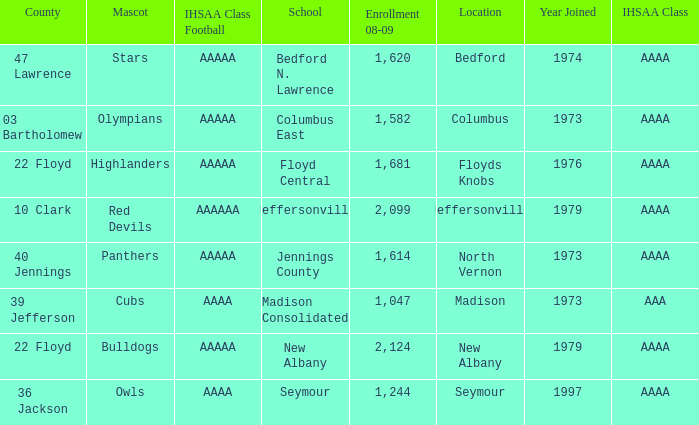What school is in 36 Jackson? Seymour. Parse the full table. {'header': ['County', 'Mascot', 'IHSAA Class Football', 'School', 'Enrollment 08-09', 'Location', 'Year Joined', 'IHSAA Class'], 'rows': [['47 Lawrence', 'Stars', 'AAAAA', 'Bedford N. Lawrence', '1,620', 'Bedford', '1974', 'AAAA'], ['03 Bartholomew', 'Olympians', 'AAAAA', 'Columbus East', '1,582', 'Columbus', '1973', 'AAAA'], ['22 Floyd', 'Highlanders', 'AAAAA', 'Floyd Central', '1,681', 'Floyds Knobs', '1976', 'AAAA'], ['10 Clark', 'Red Devils', 'AAAAAA', 'Jeffersonville', '2,099', 'Jeffersonville', '1979', 'AAAA'], ['40 Jennings', 'Panthers', 'AAAAA', 'Jennings County', '1,614', 'North Vernon', '1973', 'AAAA'], ['39 Jefferson', 'Cubs', 'AAAA', 'Madison Consolidated', '1,047', 'Madison', '1973', 'AAA'], ['22 Floyd', 'Bulldogs', 'AAAAA', 'New Albany', '2,124', 'New Albany', '1979', 'AAAA'], ['36 Jackson', 'Owls', 'AAAA', 'Seymour', '1,244', 'Seymour', '1997', 'AAAA']]} 